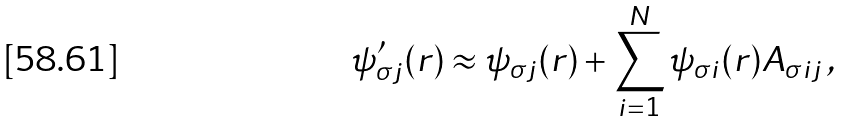<formula> <loc_0><loc_0><loc_500><loc_500>\psi ^ { \prime } _ { \sigma j } ( { r } ) \approx \psi _ { \sigma j } ( { r } ) + \sum _ { i = 1 } ^ { N } \psi _ { \sigma i } ( { r } ) A _ { \sigma i j } \, ,</formula> 